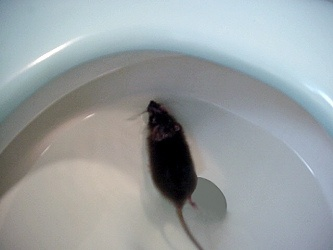Describe the objects in this image and their specific colors. I can see a toilet in darkgray, lightblue, gray, and black tones in this image. 